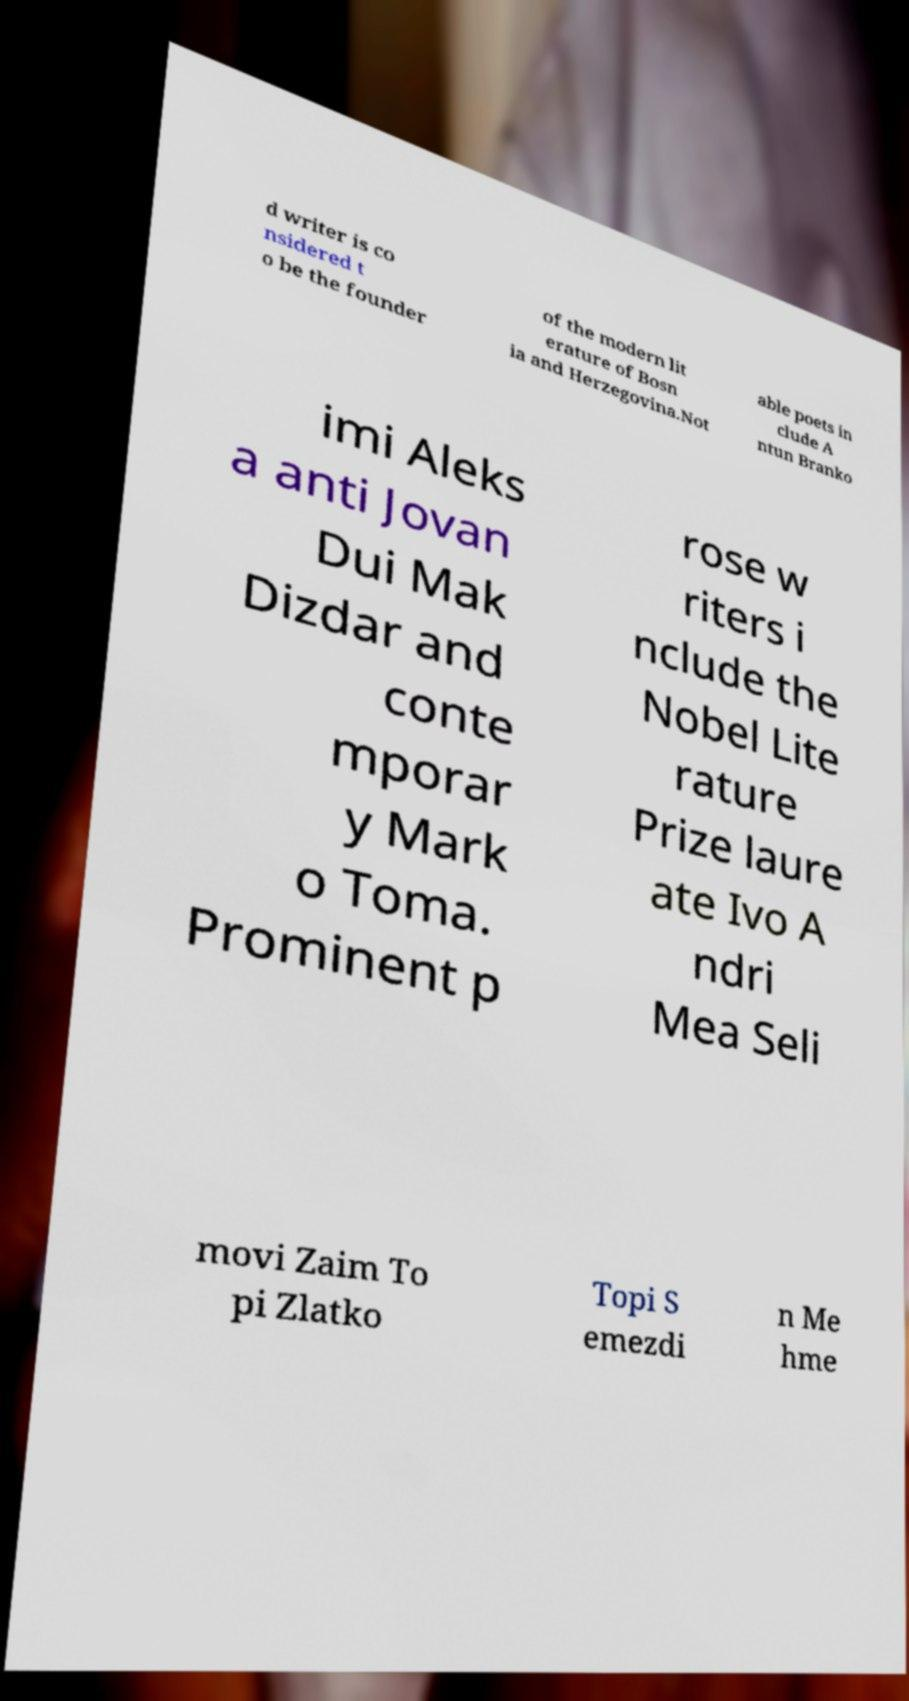There's text embedded in this image that I need extracted. Can you transcribe it verbatim? d writer is co nsidered t o be the founder of the modern lit erature of Bosn ia and Herzegovina.Not able poets in clude A ntun Branko imi Aleks a anti Jovan Dui Mak Dizdar and conte mporar y Mark o Toma. Prominent p rose w riters i nclude the Nobel Lite rature Prize laure ate Ivo A ndri Mea Seli movi Zaim To pi Zlatko Topi S emezdi n Me hme 